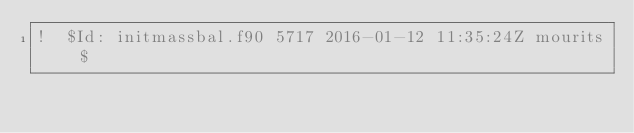<code> <loc_0><loc_0><loc_500><loc_500><_FORTRAN_>!  $Id: initmassbal.f90 5717 2016-01-12 11:35:24Z mourits $</code> 